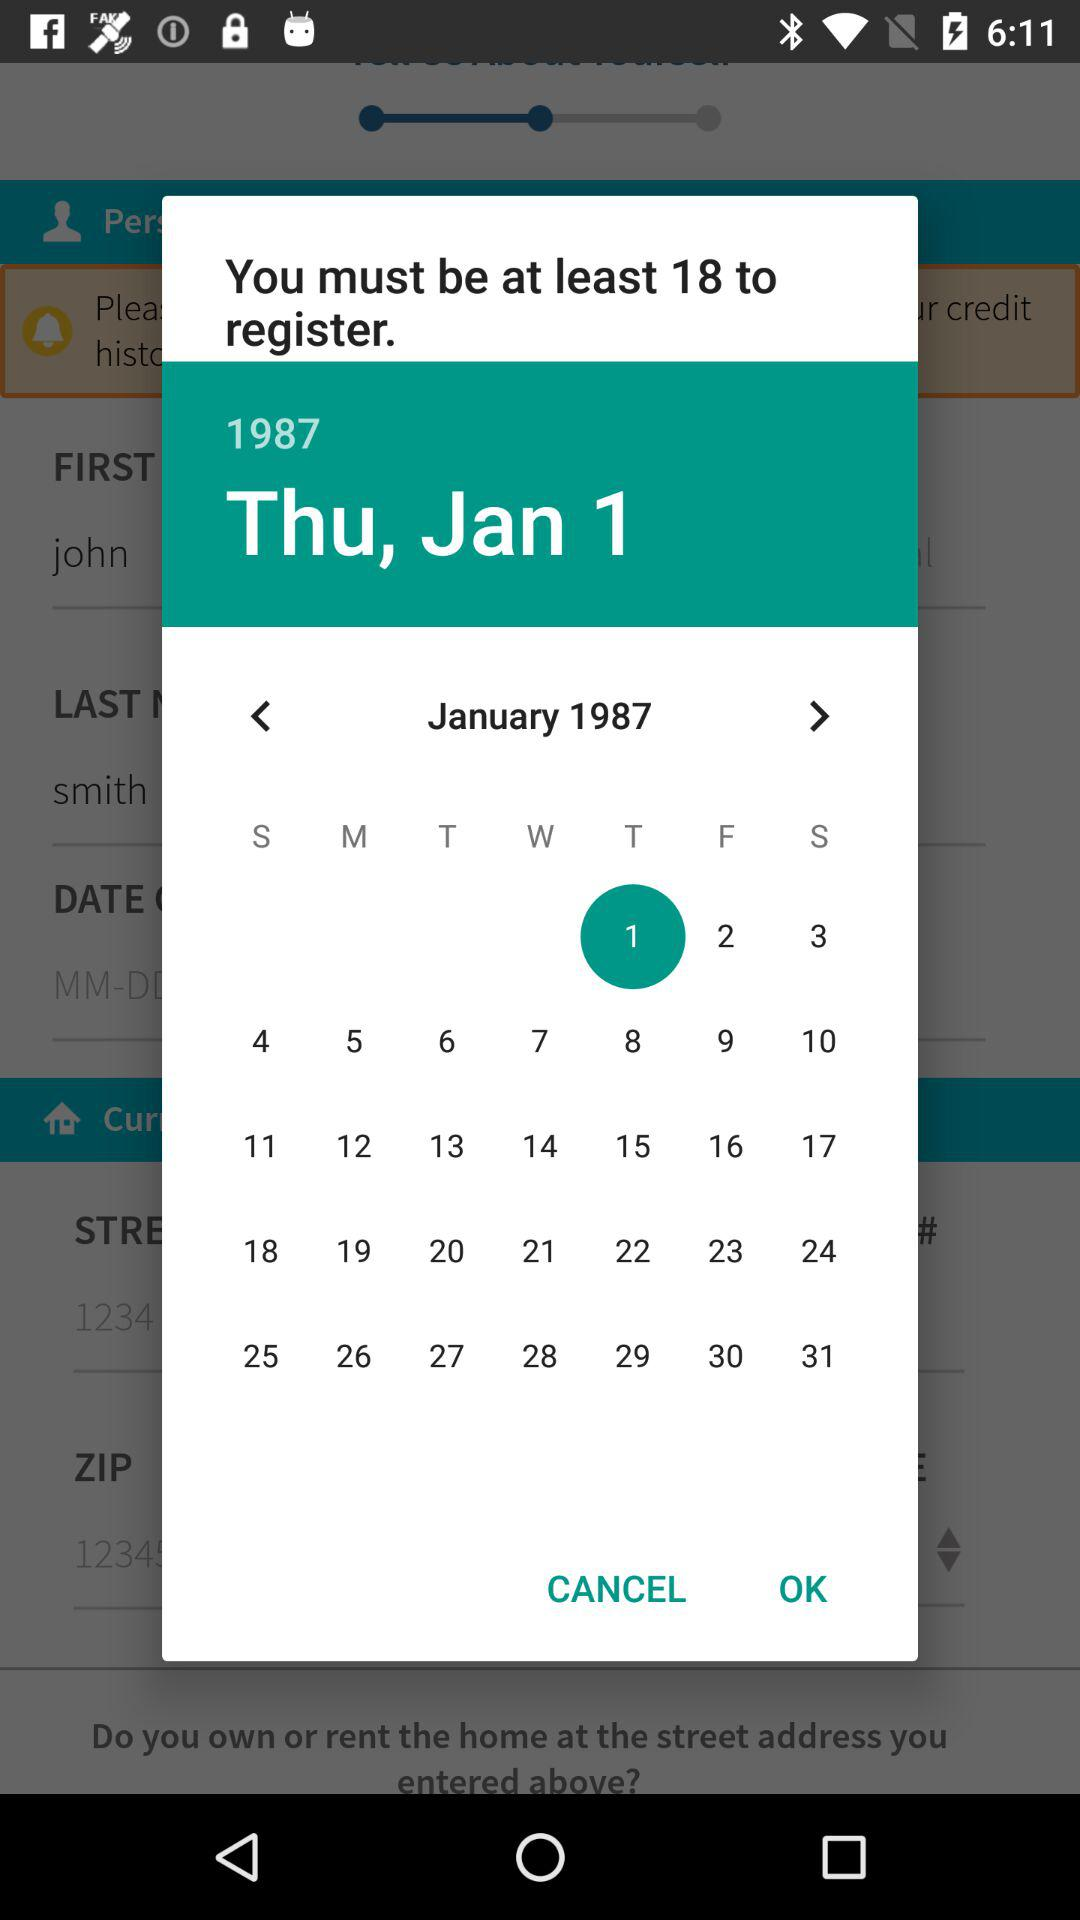What's the day on the 1st of January 1987? The day is Thursday. 